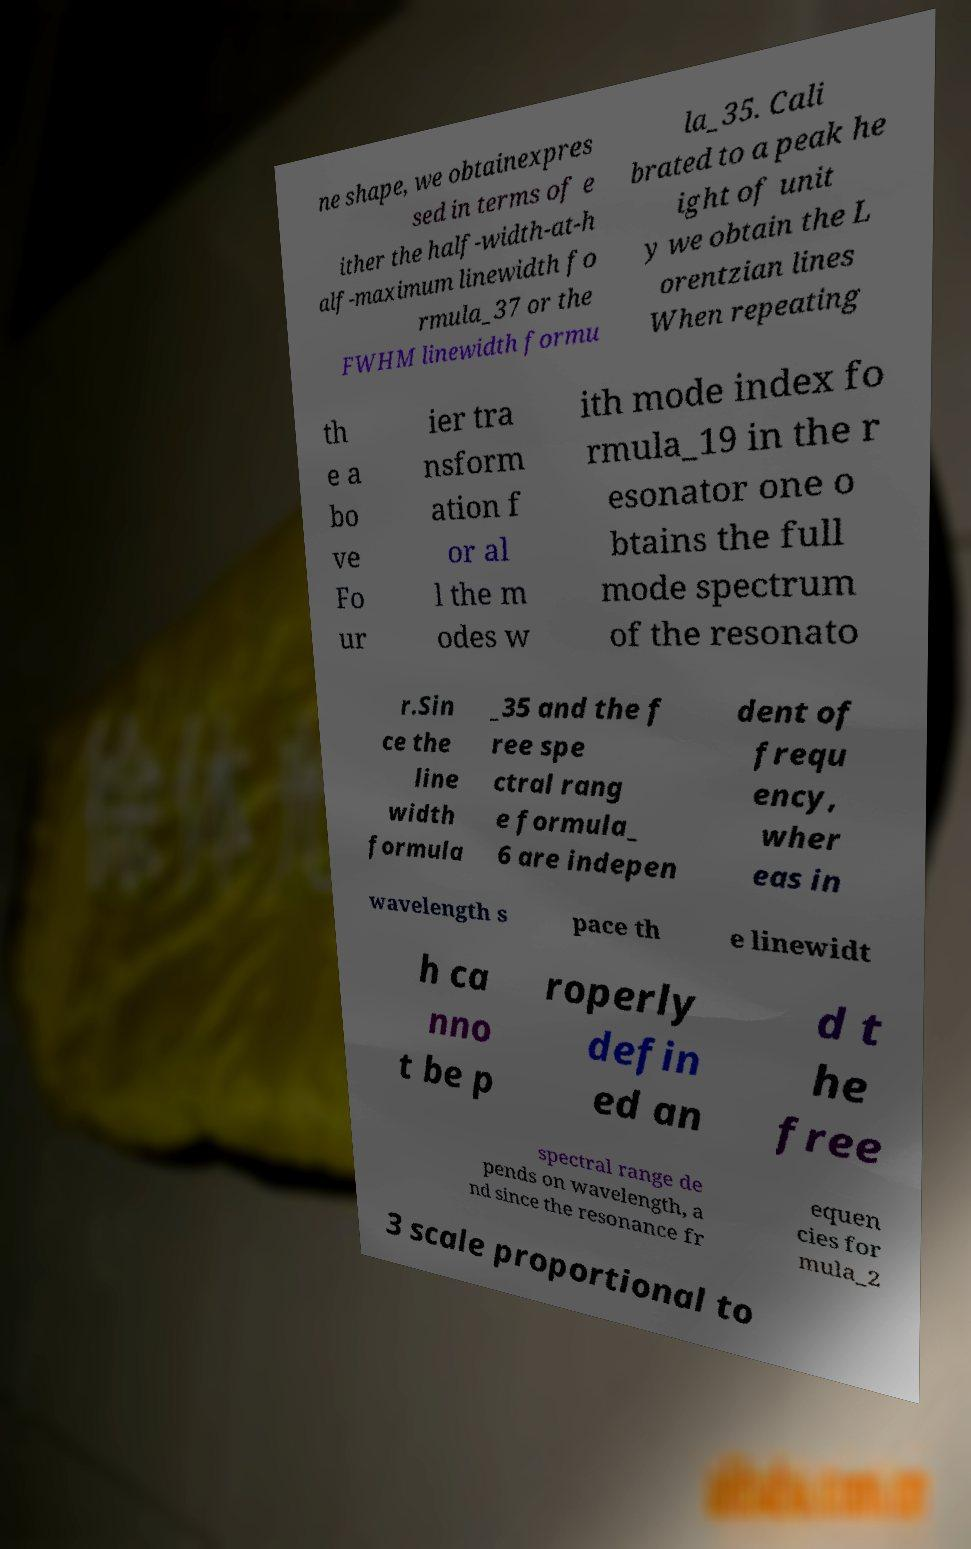What messages or text are displayed in this image? I need them in a readable, typed format. ne shape, we obtainexpres sed in terms of e ither the half-width-at-h alf-maximum linewidth fo rmula_37 or the FWHM linewidth formu la_35. Cali brated to a peak he ight of unit y we obtain the L orentzian lines When repeating th e a bo ve Fo ur ier tra nsform ation f or al l the m odes w ith mode index fo rmula_19 in the r esonator one o btains the full mode spectrum of the resonato r.Sin ce the line width formula _35 and the f ree spe ctral rang e formula_ 6 are indepen dent of frequ ency, wher eas in wavelength s pace th e linewidt h ca nno t be p roperly defin ed an d t he free spectral range de pends on wavelength, a nd since the resonance fr equen cies for mula_2 3 scale proportional to 